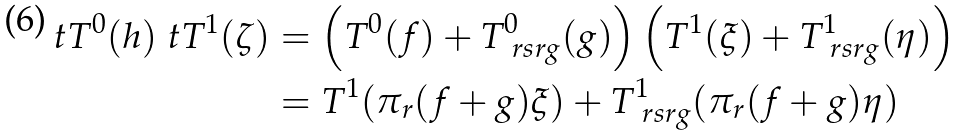Convert formula to latex. <formula><loc_0><loc_0><loc_500><loc_500>\ t T ^ { 0 } ( h ) \ t T ^ { 1 } ( \zeta ) & = \left ( T ^ { 0 } ( f ) + T _ { \ r s { r g } } ^ { 0 } ( g ) \right ) \left ( T ^ { 1 } ( \xi ) + T _ { \ r s { r g } } ^ { 1 } ( \eta ) \right ) \\ & = T ^ { 1 } ( \pi _ { r } ( f + g ) \xi ) + T _ { \ r s { r g } } ^ { 1 } ( \pi _ { r } ( f + g ) \eta )</formula> 